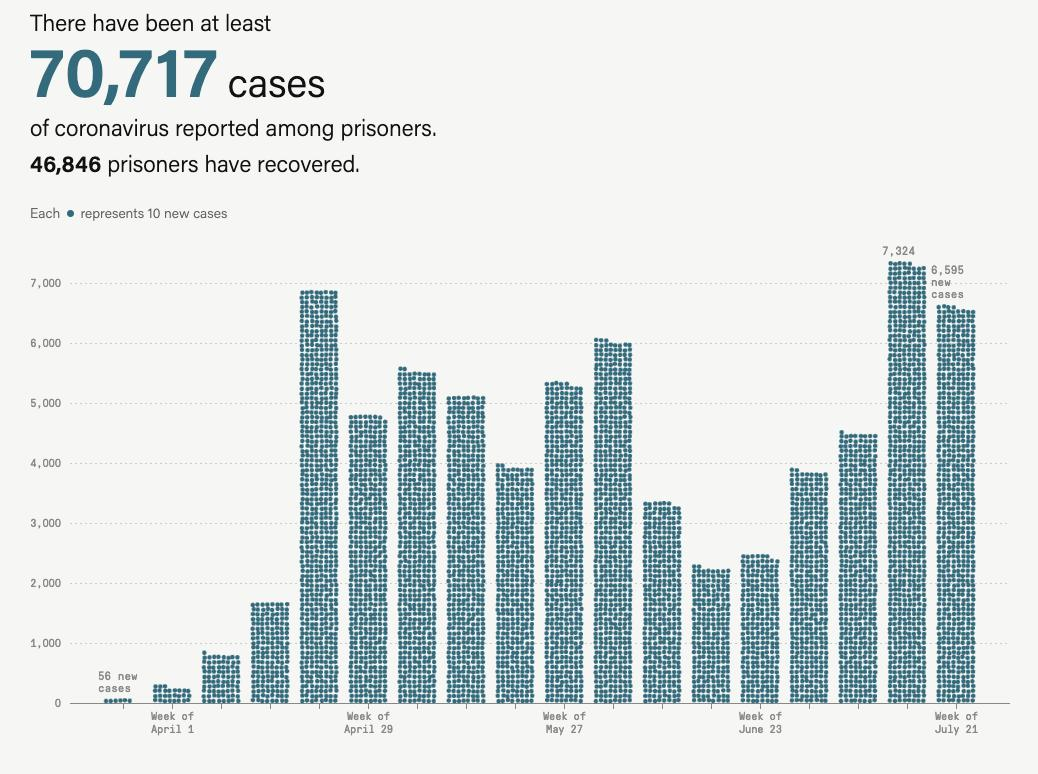Mention a couple of crucial points in this snapshot. July was the month with the highest number of reported cases, The month with the second highest number of reported cases was April. As of today, there are 23871 prisoners who have not yet fully recovered or are currently in the process of recovering from their injuries or ailments. July was the third month with the highest number of reported cases. 